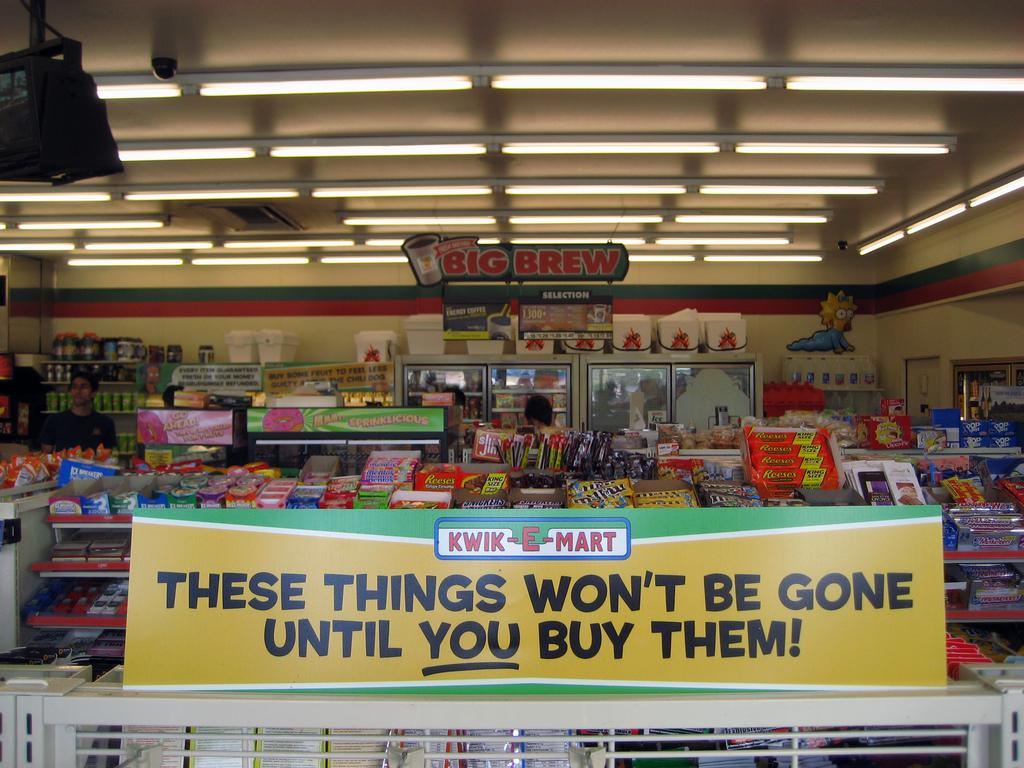<image>
Create a compact narrative representing the image presented. Kwik E Mark offers an assortment of candy, snacks and beverages. 